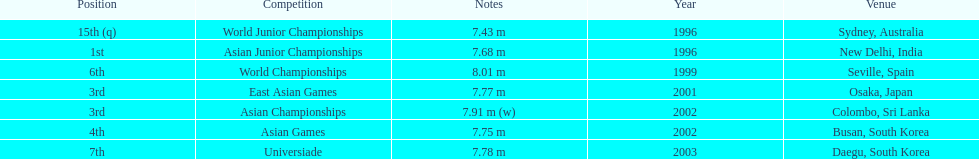Would you be able to parse every entry in this table? {'header': ['Position', 'Competition', 'Notes', 'Year', 'Venue'], 'rows': [['15th (q)', 'World Junior Championships', '7.43 m', '1996', 'Sydney, Australia'], ['1st', 'Asian Junior Championships', '7.68 m', '1996', 'New Delhi, India'], ['6th', 'World Championships', '8.01 m', '1999', 'Seville, Spain'], ['3rd', 'East Asian Games', '7.77 m', '2001', 'Osaka, Japan'], ['3rd', 'Asian Championships', '7.91 m (w)', '2002', 'Colombo, Sri Lanka'], ['4th', 'Asian Games', '7.75 m', '2002', 'Busan, South Korea'], ['7th', 'Universiade', '7.78 m', '2003', 'Daegu, South Korea']]} How many competitions did he place in the top three? 3. 